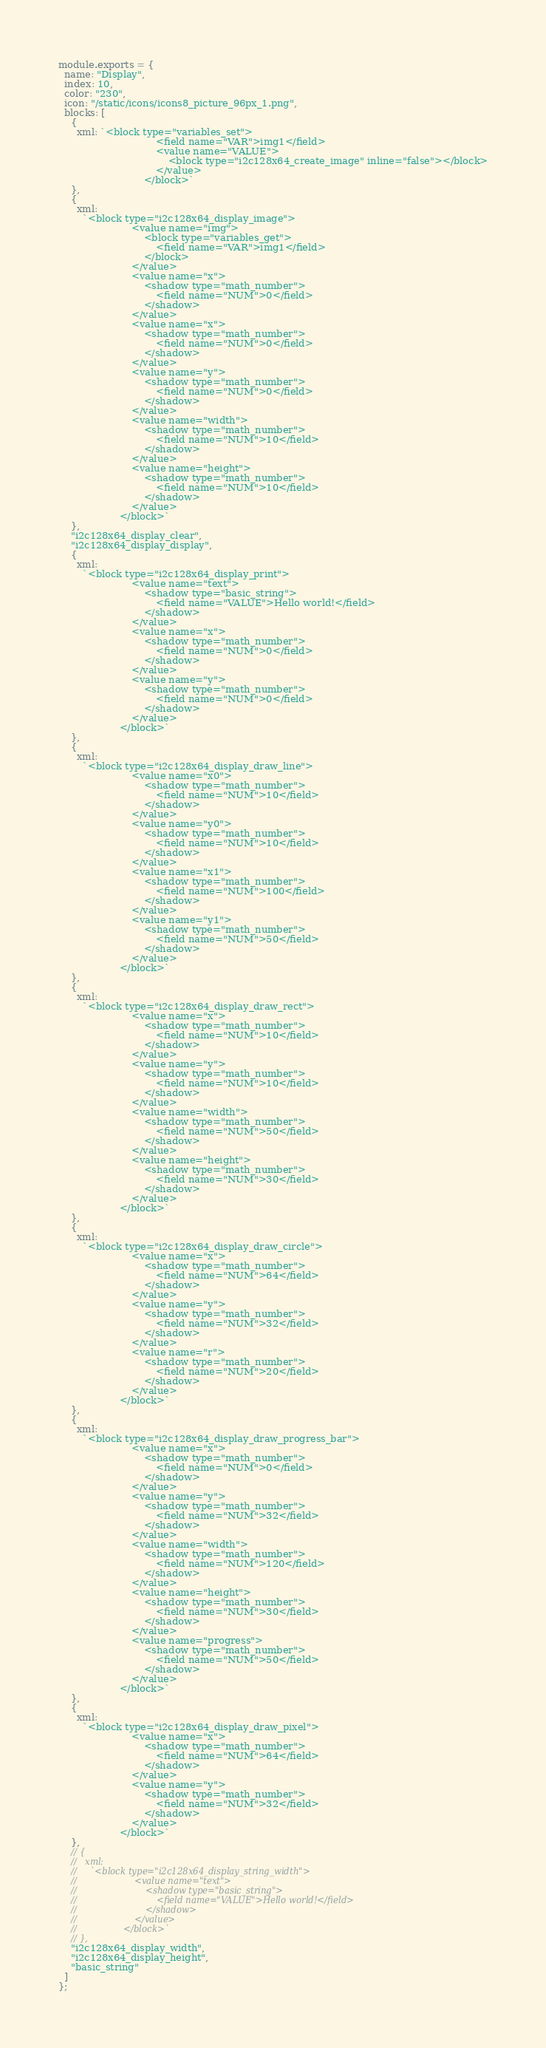Convert code to text. <code><loc_0><loc_0><loc_500><loc_500><_JavaScript_>module.exports = {
  name: "Display",
  index: 10,
  color: "230",
  icon: "/static/icons/icons8_picture_96px_1.png",
  blocks: [
    {
      xml: `<block type="variables_set">
                                <field name="VAR">img1</field>
                                <value name="VALUE">
                                    <block type="i2c128x64_create_image" inline="false"></block>
                                </value>
                            </block>`
    },
    {
      xml:
        `<block type="i2c128x64_display_image">
                        <value name="img">
                            <block type="variables_get">
                                <field name="VAR">img1</field>
                            </block>
                        </value>
                        <value name="x">
                            <shadow type="math_number">
                                <field name="NUM">0</field>
                            </shadow>
                        </value>
                        <value name="x">
                            <shadow type="math_number">
                                <field name="NUM">0</field>
                            </shadow>
                        </value>
                        <value name="y">
                            <shadow type="math_number">
                                <field name="NUM">0</field>
                            </shadow>
                        </value>
                        <value name="width">
                            <shadow type="math_number">
                                <field name="NUM">10</field>
                            </shadow>
                        </value>
                        <value name="height">
                            <shadow type="math_number">
                                <field name="NUM">10</field>
                            </shadow>
                        </value>
                    </block>`
    },
    "i2c128x64_display_clear",
    "i2c128x64_display_display",
    {
      xml:
        `<block type="i2c128x64_display_print">
                        <value name="text">
                            <shadow type="basic_string">
                                <field name="VALUE">Hello world!</field>
                            </shadow>
                        </value>
                        <value name="x">
                            <shadow type="math_number">
                                <field name="NUM">0</field>
                            </shadow>
                        </value>
                        <value name="y">
                            <shadow type="math_number">
                                <field name="NUM">0</field>
                            </shadow>
                        </value>
                    </block>`
    },
    {
      xml:
        `<block type="i2c128x64_display_draw_line">
                        <value name="x0">
                            <shadow type="math_number">
                                <field name="NUM">10</field>
                            </shadow>
                        </value>
                        <value name="y0">
                            <shadow type="math_number">
                                <field name="NUM">10</field>
                            </shadow>
                        </value>
                        <value name="x1">
                            <shadow type="math_number">
                                <field name="NUM">100</field>
                            </shadow>
                        </value>
                        <value name="y1">
                            <shadow type="math_number">
                                <field name="NUM">50</field>
                            </shadow>
                        </value>
                    </block>`
    },
    {
      xml:
        `<block type="i2c128x64_display_draw_rect">
                        <value name="x">
                            <shadow type="math_number">
                                <field name="NUM">10</field>
                            </shadow>
                        </value>
                        <value name="y">
                            <shadow type="math_number">
                                <field name="NUM">10</field>
                            </shadow>
                        </value>
                        <value name="width">
                            <shadow type="math_number">
                                <field name="NUM">50</field>
                            </shadow>
                        </value>
                        <value name="height">
                            <shadow type="math_number">
                                <field name="NUM">30</field>
                            </shadow>
                        </value>
                    </block>`
    },
    {
      xml:
        `<block type="i2c128x64_display_draw_circle">
                        <value name="x">
                            <shadow type="math_number">
                                <field name="NUM">64</field>
                            </shadow>
                        </value>
                        <value name="y">
                            <shadow type="math_number">
                                <field name="NUM">32</field>
                            </shadow>
                        </value>
                        <value name="r">
                            <shadow type="math_number">
                                <field name="NUM">20</field>
                            </shadow>
                        </value>
                    </block>`
    },
    {
      xml:
        `<block type="i2c128x64_display_draw_progress_bar">
                        <value name="x">
                            <shadow type="math_number">
                                <field name="NUM">0</field>
                            </shadow>
                        </value>
                        <value name="y">
                            <shadow type="math_number">
                                <field name="NUM">32</field>
                            </shadow>
                        </value>
                        <value name="width">
                            <shadow type="math_number">
                                <field name="NUM">120</field>
                            </shadow>
                        </value>
                        <value name="height">
                            <shadow type="math_number">
                                <field name="NUM">30</field>
                            </shadow>
                        </value>
                        <value name="progress">
                            <shadow type="math_number">
                                <field name="NUM">50</field>
                            </shadow>
                        </value>
                    </block>`
    },
    {
      xml:
        `<block type="i2c128x64_display_draw_pixel">
                        <value name="x">
                            <shadow type="math_number">
                                <field name="NUM">64</field>
                            </shadow>
                        </value>
                        <value name="y">
                            <shadow type="math_number">
                                <field name="NUM">32</field>
                            </shadow>
                        </value>    
                    </block>`
    },
    // {
    //   xml:
    //     `<block type="i2c128x64_display_string_width">
    //                     <value name="text">
    //                         <shadow type="basic_string">
    //                             <field name="VALUE">Hello world!</field>
    //                         </shadow>
    //                     </value>
    //                 </block>`
    // },
    "i2c128x64_display_width",
    "i2c128x64_display_height",
    "basic_string"
  ]
};
</code> 